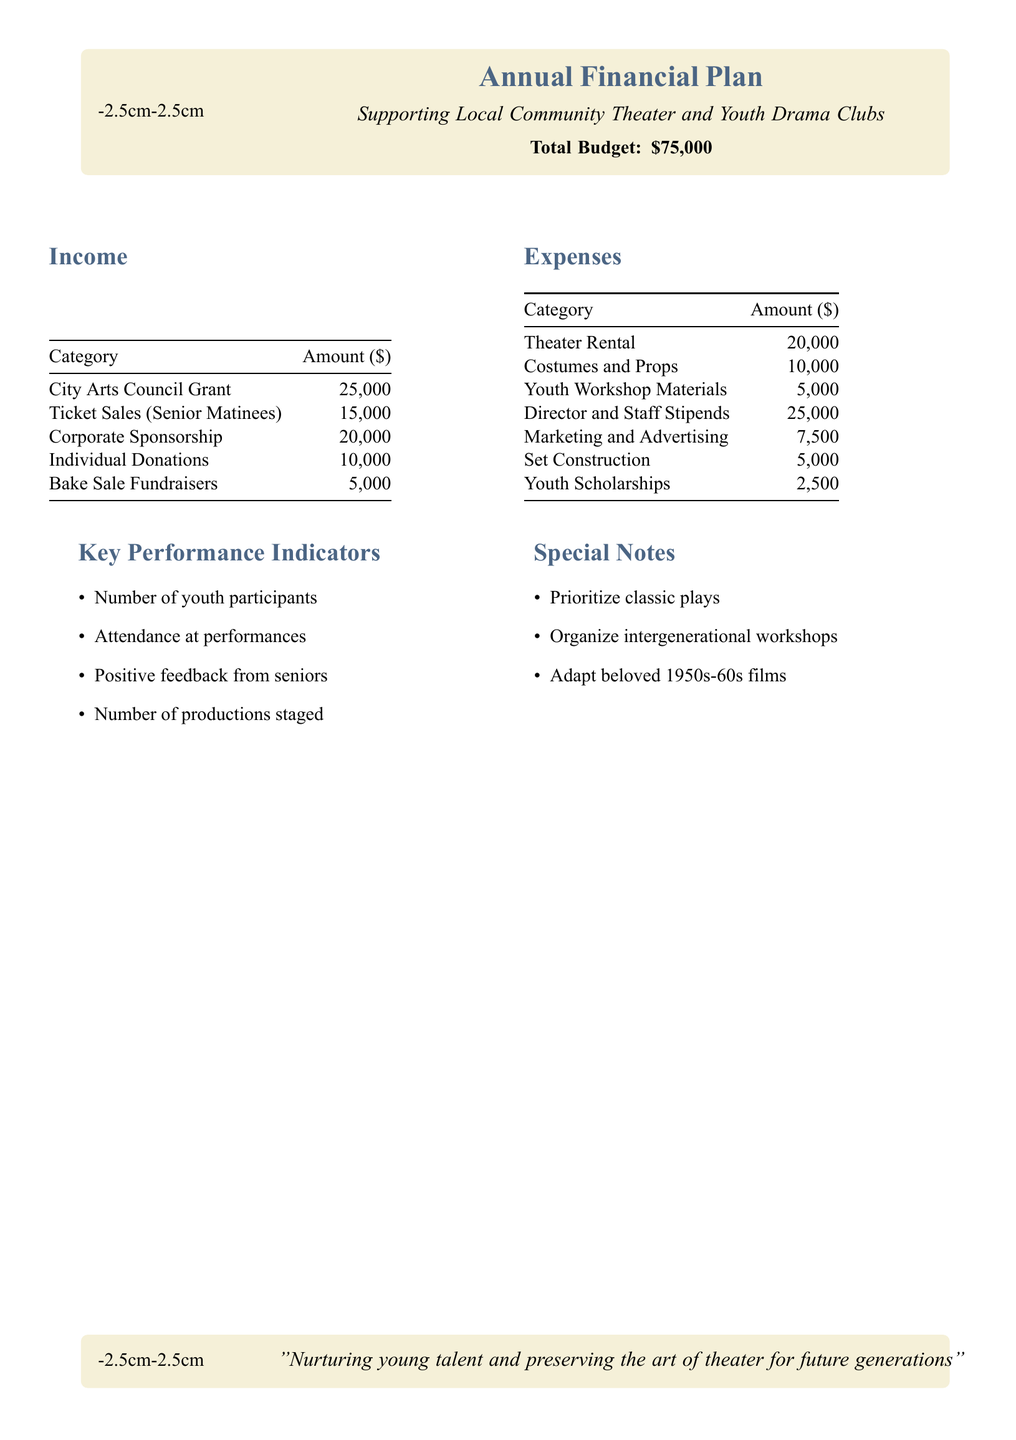What is the total budget? The total budget is stated clearly in the document as the overall financial plan for supporting local community theater and youth drama clubs.
Answer: $75,000 How much is allocated for the City Arts Council Grant? The income section specifies the amount received from the City Arts Council Grant, which is one of the sources of revenue.
Answer: $25,000 What is the amount set for youth scholarships? The expenses section outlines the budget dedicated specifically to youth scholarships as part of the overall expenses.
Answer: $2,500 What is the total amount from ticket sales (senior matinees)? Ticket sales for senior matinees are highlighted in the income section as a key revenue source in the budget.
Answer: $15,000 How much is earmarked for costumes and props? The expenses detail the budget allocation specifically for costumes and props used in the theater productions.
Answer: $10,000 What are the key performance indicators? The document lists specific metrics to measure success in the theater productions, found in the key performance indicator section.
Answer: Number of youth participants, Attendance at performances, Positive feedback from seniors, Number of productions staged What is one of the special notes mentioned in the document? Special notes are included to highlight additional priorities or plans related to the theater productions, providing insight into future directions.
Answer: Prioritize classic plays How much is budgeted for director and staff stipends? The expenses section details how much is allocated specifically for the director and the staff involved in the productions.
Answer: $25,000 What is the total from individual donations? Individual donations are a part of the income sources, contributing to the overall revenue for the budget.
Answer: $10,000 